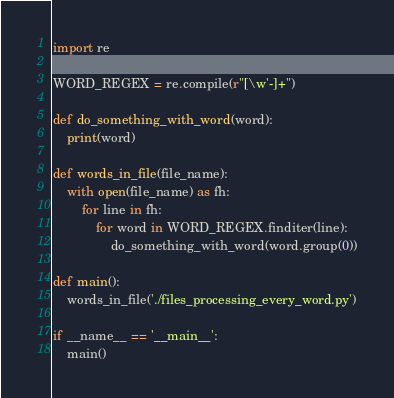<code> <loc_0><loc_0><loc_500><loc_500><_Python_>import re

WORD_REGEX = re.compile(r"[\w'-]+")

def do_something_with_word(word):
    print(word)

def words_in_file(file_name):
    with open(file_name) as fh:
        for line in fh:
            for word in WORD_REGEX.finditer(line):
                do_something_with_word(word.group(0))

def main():
    words_in_file('./files_processing_every_word.py')

if __name__ == '__main__':
    main()</code> 